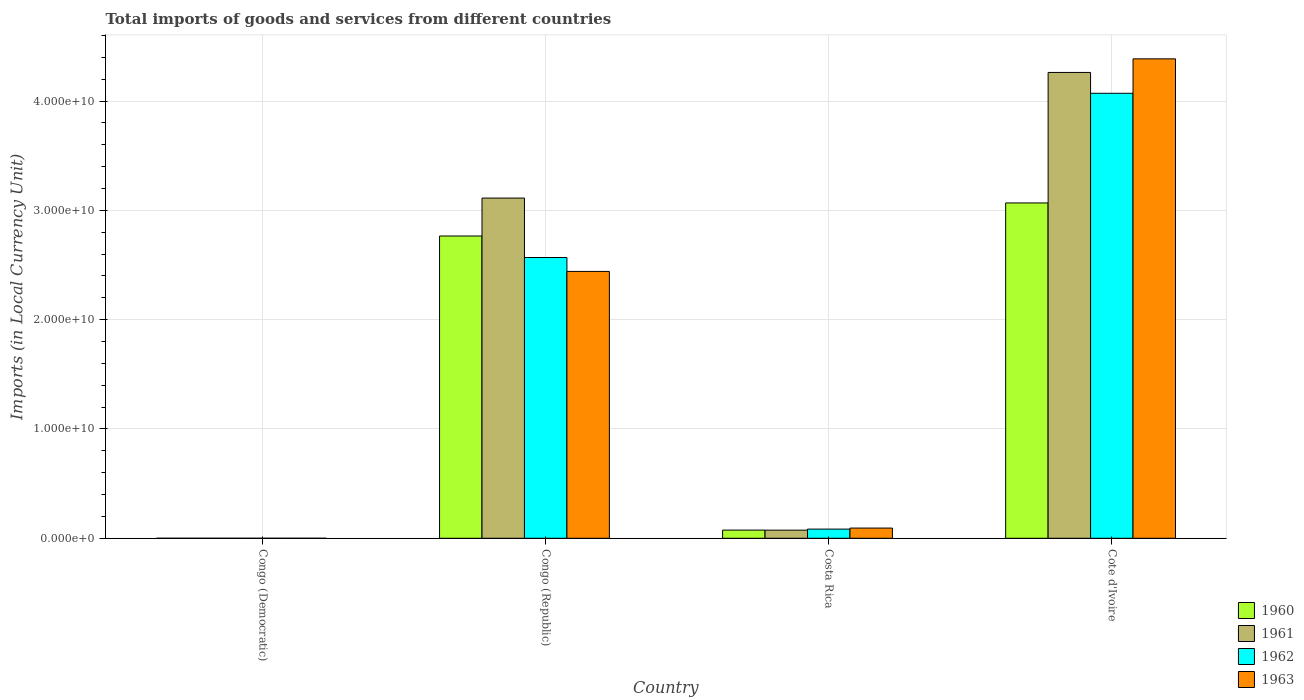How many different coloured bars are there?
Give a very brief answer. 4. How many groups of bars are there?
Your answer should be compact. 4. Are the number of bars on each tick of the X-axis equal?
Your answer should be compact. Yes. What is the label of the 4th group of bars from the left?
Your answer should be compact. Cote d'Ivoire. What is the Amount of goods and services imports in 1961 in Congo (Republic)?
Give a very brief answer. 3.11e+1. Across all countries, what is the maximum Amount of goods and services imports in 1961?
Keep it short and to the point. 4.26e+1. Across all countries, what is the minimum Amount of goods and services imports in 1960?
Ensure brevity in your answer.  0. In which country was the Amount of goods and services imports in 1962 maximum?
Provide a short and direct response. Cote d'Ivoire. In which country was the Amount of goods and services imports in 1961 minimum?
Ensure brevity in your answer.  Congo (Democratic). What is the total Amount of goods and services imports in 1963 in the graph?
Your answer should be compact. 6.92e+1. What is the difference between the Amount of goods and services imports in 1960 in Congo (Democratic) and that in Costa Rica?
Provide a succinct answer. -7.49e+08. What is the difference between the Amount of goods and services imports in 1963 in Costa Rica and the Amount of goods and services imports in 1961 in Congo (Republic)?
Your answer should be compact. -3.02e+1. What is the average Amount of goods and services imports in 1960 per country?
Your answer should be compact. 1.48e+1. What is the difference between the Amount of goods and services imports of/in 1963 and Amount of goods and services imports of/in 1960 in Costa Rica?
Offer a terse response. 1.85e+08. In how many countries, is the Amount of goods and services imports in 1960 greater than 42000000000 LCU?
Offer a terse response. 0. What is the ratio of the Amount of goods and services imports in 1962 in Congo (Republic) to that in Cote d'Ivoire?
Provide a succinct answer. 0.63. Is the Amount of goods and services imports in 1961 in Congo (Democratic) less than that in Congo (Republic)?
Offer a very short reply. Yes. Is the difference between the Amount of goods and services imports in 1963 in Congo (Republic) and Costa Rica greater than the difference between the Amount of goods and services imports in 1960 in Congo (Republic) and Costa Rica?
Your answer should be very brief. No. What is the difference between the highest and the second highest Amount of goods and services imports in 1962?
Give a very brief answer. -3.99e+1. What is the difference between the highest and the lowest Amount of goods and services imports in 1961?
Ensure brevity in your answer.  4.26e+1. In how many countries, is the Amount of goods and services imports in 1962 greater than the average Amount of goods and services imports in 1962 taken over all countries?
Keep it short and to the point. 2. Is it the case that in every country, the sum of the Amount of goods and services imports in 1962 and Amount of goods and services imports in 1963 is greater than the sum of Amount of goods and services imports in 1961 and Amount of goods and services imports in 1960?
Your answer should be very brief. No. What does the 4th bar from the left in Congo (Democratic) represents?
Offer a very short reply. 1963. Is it the case that in every country, the sum of the Amount of goods and services imports in 1963 and Amount of goods and services imports in 1961 is greater than the Amount of goods and services imports in 1962?
Keep it short and to the point. Yes. How many countries are there in the graph?
Your answer should be compact. 4. What is the difference between two consecutive major ticks on the Y-axis?
Your answer should be very brief. 1.00e+1. Are the values on the major ticks of Y-axis written in scientific E-notation?
Give a very brief answer. Yes. Where does the legend appear in the graph?
Provide a succinct answer. Bottom right. How are the legend labels stacked?
Your response must be concise. Vertical. What is the title of the graph?
Your response must be concise. Total imports of goods and services from different countries. What is the label or title of the X-axis?
Provide a short and direct response. Country. What is the label or title of the Y-axis?
Make the answer very short. Imports (in Local Currency Unit). What is the Imports (in Local Currency Unit) of 1960 in Congo (Democratic)?
Offer a terse response. 0. What is the Imports (in Local Currency Unit) in 1961 in Congo (Democratic)?
Provide a succinct answer. 5.07076656504069e-5. What is the Imports (in Local Currency Unit) of 1962 in Congo (Democratic)?
Your answer should be compact. 5.906629303353841e-5. What is the Imports (in Local Currency Unit) of 1963 in Congo (Democratic)?
Ensure brevity in your answer.  0. What is the Imports (in Local Currency Unit) of 1960 in Congo (Republic)?
Your response must be concise. 2.77e+1. What is the Imports (in Local Currency Unit) of 1961 in Congo (Republic)?
Provide a succinct answer. 3.11e+1. What is the Imports (in Local Currency Unit) in 1962 in Congo (Republic)?
Provide a succinct answer. 2.57e+1. What is the Imports (in Local Currency Unit) in 1963 in Congo (Republic)?
Provide a succinct answer. 2.44e+1. What is the Imports (in Local Currency Unit) of 1960 in Costa Rica?
Provide a short and direct response. 7.49e+08. What is the Imports (in Local Currency Unit) in 1961 in Costa Rica?
Ensure brevity in your answer.  7.44e+08. What is the Imports (in Local Currency Unit) in 1962 in Costa Rica?
Make the answer very short. 8.40e+08. What is the Imports (in Local Currency Unit) of 1963 in Costa Rica?
Make the answer very short. 9.34e+08. What is the Imports (in Local Currency Unit) in 1960 in Cote d'Ivoire?
Your answer should be compact. 3.07e+1. What is the Imports (in Local Currency Unit) in 1961 in Cote d'Ivoire?
Ensure brevity in your answer.  4.26e+1. What is the Imports (in Local Currency Unit) of 1962 in Cote d'Ivoire?
Your answer should be very brief. 4.07e+1. What is the Imports (in Local Currency Unit) in 1963 in Cote d'Ivoire?
Keep it short and to the point. 4.39e+1. Across all countries, what is the maximum Imports (in Local Currency Unit) of 1960?
Your response must be concise. 3.07e+1. Across all countries, what is the maximum Imports (in Local Currency Unit) in 1961?
Your answer should be compact. 4.26e+1. Across all countries, what is the maximum Imports (in Local Currency Unit) of 1962?
Keep it short and to the point. 4.07e+1. Across all countries, what is the maximum Imports (in Local Currency Unit) of 1963?
Offer a very short reply. 4.39e+1. Across all countries, what is the minimum Imports (in Local Currency Unit) of 1960?
Give a very brief answer. 0. Across all countries, what is the minimum Imports (in Local Currency Unit) of 1961?
Your answer should be compact. 5.07076656504069e-5. Across all countries, what is the minimum Imports (in Local Currency Unit) of 1962?
Provide a succinct answer. 5.906629303353841e-5. Across all countries, what is the minimum Imports (in Local Currency Unit) of 1963?
Ensure brevity in your answer.  0. What is the total Imports (in Local Currency Unit) of 1960 in the graph?
Your response must be concise. 5.91e+1. What is the total Imports (in Local Currency Unit) in 1961 in the graph?
Offer a very short reply. 7.45e+1. What is the total Imports (in Local Currency Unit) in 1962 in the graph?
Give a very brief answer. 6.72e+1. What is the total Imports (in Local Currency Unit) in 1963 in the graph?
Ensure brevity in your answer.  6.92e+1. What is the difference between the Imports (in Local Currency Unit) in 1960 in Congo (Democratic) and that in Congo (Republic)?
Provide a short and direct response. -2.77e+1. What is the difference between the Imports (in Local Currency Unit) in 1961 in Congo (Democratic) and that in Congo (Republic)?
Provide a short and direct response. -3.11e+1. What is the difference between the Imports (in Local Currency Unit) in 1962 in Congo (Democratic) and that in Congo (Republic)?
Offer a very short reply. -2.57e+1. What is the difference between the Imports (in Local Currency Unit) of 1963 in Congo (Democratic) and that in Congo (Republic)?
Your response must be concise. -2.44e+1. What is the difference between the Imports (in Local Currency Unit) in 1960 in Congo (Democratic) and that in Costa Rica?
Provide a short and direct response. -7.49e+08. What is the difference between the Imports (in Local Currency Unit) of 1961 in Congo (Democratic) and that in Costa Rica?
Make the answer very short. -7.44e+08. What is the difference between the Imports (in Local Currency Unit) in 1962 in Congo (Democratic) and that in Costa Rica?
Provide a short and direct response. -8.40e+08. What is the difference between the Imports (in Local Currency Unit) in 1963 in Congo (Democratic) and that in Costa Rica?
Make the answer very short. -9.34e+08. What is the difference between the Imports (in Local Currency Unit) in 1960 in Congo (Democratic) and that in Cote d'Ivoire?
Give a very brief answer. -3.07e+1. What is the difference between the Imports (in Local Currency Unit) of 1961 in Congo (Democratic) and that in Cote d'Ivoire?
Keep it short and to the point. -4.26e+1. What is the difference between the Imports (in Local Currency Unit) of 1962 in Congo (Democratic) and that in Cote d'Ivoire?
Your response must be concise. -4.07e+1. What is the difference between the Imports (in Local Currency Unit) of 1963 in Congo (Democratic) and that in Cote d'Ivoire?
Your answer should be very brief. -4.39e+1. What is the difference between the Imports (in Local Currency Unit) of 1960 in Congo (Republic) and that in Costa Rica?
Make the answer very short. 2.69e+1. What is the difference between the Imports (in Local Currency Unit) in 1961 in Congo (Republic) and that in Costa Rica?
Your answer should be compact. 3.04e+1. What is the difference between the Imports (in Local Currency Unit) in 1962 in Congo (Republic) and that in Costa Rica?
Offer a terse response. 2.48e+1. What is the difference between the Imports (in Local Currency Unit) in 1963 in Congo (Republic) and that in Costa Rica?
Provide a short and direct response. 2.35e+1. What is the difference between the Imports (in Local Currency Unit) of 1960 in Congo (Republic) and that in Cote d'Ivoire?
Your answer should be compact. -3.02e+09. What is the difference between the Imports (in Local Currency Unit) in 1961 in Congo (Republic) and that in Cote d'Ivoire?
Your answer should be very brief. -1.15e+1. What is the difference between the Imports (in Local Currency Unit) in 1962 in Congo (Republic) and that in Cote d'Ivoire?
Your answer should be very brief. -1.50e+1. What is the difference between the Imports (in Local Currency Unit) in 1963 in Congo (Republic) and that in Cote d'Ivoire?
Your answer should be very brief. -1.94e+1. What is the difference between the Imports (in Local Currency Unit) in 1960 in Costa Rica and that in Cote d'Ivoire?
Your response must be concise. -2.99e+1. What is the difference between the Imports (in Local Currency Unit) of 1961 in Costa Rica and that in Cote d'Ivoire?
Provide a succinct answer. -4.19e+1. What is the difference between the Imports (in Local Currency Unit) in 1962 in Costa Rica and that in Cote d'Ivoire?
Give a very brief answer. -3.99e+1. What is the difference between the Imports (in Local Currency Unit) of 1963 in Costa Rica and that in Cote d'Ivoire?
Make the answer very short. -4.29e+1. What is the difference between the Imports (in Local Currency Unit) of 1960 in Congo (Democratic) and the Imports (in Local Currency Unit) of 1961 in Congo (Republic)?
Your answer should be compact. -3.11e+1. What is the difference between the Imports (in Local Currency Unit) in 1960 in Congo (Democratic) and the Imports (in Local Currency Unit) in 1962 in Congo (Republic)?
Give a very brief answer. -2.57e+1. What is the difference between the Imports (in Local Currency Unit) in 1960 in Congo (Democratic) and the Imports (in Local Currency Unit) in 1963 in Congo (Republic)?
Offer a terse response. -2.44e+1. What is the difference between the Imports (in Local Currency Unit) of 1961 in Congo (Democratic) and the Imports (in Local Currency Unit) of 1962 in Congo (Republic)?
Ensure brevity in your answer.  -2.57e+1. What is the difference between the Imports (in Local Currency Unit) of 1961 in Congo (Democratic) and the Imports (in Local Currency Unit) of 1963 in Congo (Republic)?
Keep it short and to the point. -2.44e+1. What is the difference between the Imports (in Local Currency Unit) of 1962 in Congo (Democratic) and the Imports (in Local Currency Unit) of 1963 in Congo (Republic)?
Keep it short and to the point. -2.44e+1. What is the difference between the Imports (in Local Currency Unit) of 1960 in Congo (Democratic) and the Imports (in Local Currency Unit) of 1961 in Costa Rica?
Offer a very short reply. -7.44e+08. What is the difference between the Imports (in Local Currency Unit) of 1960 in Congo (Democratic) and the Imports (in Local Currency Unit) of 1962 in Costa Rica?
Give a very brief answer. -8.40e+08. What is the difference between the Imports (in Local Currency Unit) of 1960 in Congo (Democratic) and the Imports (in Local Currency Unit) of 1963 in Costa Rica?
Keep it short and to the point. -9.34e+08. What is the difference between the Imports (in Local Currency Unit) in 1961 in Congo (Democratic) and the Imports (in Local Currency Unit) in 1962 in Costa Rica?
Make the answer very short. -8.40e+08. What is the difference between the Imports (in Local Currency Unit) of 1961 in Congo (Democratic) and the Imports (in Local Currency Unit) of 1963 in Costa Rica?
Your answer should be very brief. -9.34e+08. What is the difference between the Imports (in Local Currency Unit) of 1962 in Congo (Democratic) and the Imports (in Local Currency Unit) of 1963 in Costa Rica?
Your answer should be compact. -9.34e+08. What is the difference between the Imports (in Local Currency Unit) of 1960 in Congo (Democratic) and the Imports (in Local Currency Unit) of 1961 in Cote d'Ivoire?
Offer a very short reply. -4.26e+1. What is the difference between the Imports (in Local Currency Unit) of 1960 in Congo (Democratic) and the Imports (in Local Currency Unit) of 1962 in Cote d'Ivoire?
Make the answer very short. -4.07e+1. What is the difference between the Imports (in Local Currency Unit) in 1960 in Congo (Democratic) and the Imports (in Local Currency Unit) in 1963 in Cote d'Ivoire?
Provide a succinct answer. -4.39e+1. What is the difference between the Imports (in Local Currency Unit) in 1961 in Congo (Democratic) and the Imports (in Local Currency Unit) in 1962 in Cote d'Ivoire?
Your response must be concise. -4.07e+1. What is the difference between the Imports (in Local Currency Unit) of 1961 in Congo (Democratic) and the Imports (in Local Currency Unit) of 1963 in Cote d'Ivoire?
Your response must be concise. -4.39e+1. What is the difference between the Imports (in Local Currency Unit) of 1962 in Congo (Democratic) and the Imports (in Local Currency Unit) of 1963 in Cote d'Ivoire?
Your answer should be compact. -4.39e+1. What is the difference between the Imports (in Local Currency Unit) in 1960 in Congo (Republic) and the Imports (in Local Currency Unit) in 1961 in Costa Rica?
Offer a terse response. 2.69e+1. What is the difference between the Imports (in Local Currency Unit) in 1960 in Congo (Republic) and the Imports (in Local Currency Unit) in 1962 in Costa Rica?
Make the answer very short. 2.68e+1. What is the difference between the Imports (in Local Currency Unit) in 1960 in Congo (Republic) and the Imports (in Local Currency Unit) in 1963 in Costa Rica?
Your answer should be compact. 2.67e+1. What is the difference between the Imports (in Local Currency Unit) in 1961 in Congo (Republic) and the Imports (in Local Currency Unit) in 1962 in Costa Rica?
Provide a succinct answer. 3.03e+1. What is the difference between the Imports (in Local Currency Unit) in 1961 in Congo (Republic) and the Imports (in Local Currency Unit) in 1963 in Costa Rica?
Provide a short and direct response. 3.02e+1. What is the difference between the Imports (in Local Currency Unit) of 1962 in Congo (Republic) and the Imports (in Local Currency Unit) of 1963 in Costa Rica?
Keep it short and to the point. 2.48e+1. What is the difference between the Imports (in Local Currency Unit) of 1960 in Congo (Republic) and the Imports (in Local Currency Unit) of 1961 in Cote d'Ivoire?
Your response must be concise. -1.50e+1. What is the difference between the Imports (in Local Currency Unit) in 1960 in Congo (Republic) and the Imports (in Local Currency Unit) in 1962 in Cote d'Ivoire?
Your answer should be compact. -1.31e+1. What is the difference between the Imports (in Local Currency Unit) in 1960 in Congo (Republic) and the Imports (in Local Currency Unit) in 1963 in Cote d'Ivoire?
Keep it short and to the point. -1.62e+1. What is the difference between the Imports (in Local Currency Unit) in 1961 in Congo (Republic) and the Imports (in Local Currency Unit) in 1962 in Cote d'Ivoire?
Offer a very short reply. -9.58e+09. What is the difference between the Imports (in Local Currency Unit) in 1961 in Congo (Republic) and the Imports (in Local Currency Unit) in 1963 in Cote d'Ivoire?
Provide a short and direct response. -1.27e+1. What is the difference between the Imports (in Local Currency Unit) in 1962 in Congo (Republic) and the Imports (in Local Currency Unit) in 1963 in Cote d'Ivoire?
Your response must be concise. -1.82e+1. What is the difference between the Imports (in Local Currency Unit) in 1960 in Costa Rica and the Imports (in Local Currency Unit) in 1961 in Cote d'Ivoire?
Give a very brief answer. -4.19e+1. What is the difference between the Imports (in Local Currency Unit) in 1960 in Costa Rica and the Imports (in Local Currency Unit) in 1962 in Cote d'Ivoire?
Your response must be concise. -4.00e+1. What is the difference between the Imports (in Local Currency Unit) of 1960 in Costa Rica and the Imports (in Local Currency Unit) of 1963 in Cote d'Ivoire?
Your answer should be compact. -4.31e+1. What is the difference between the Imports (in Local Currency Unit) in 1961 in Costa Rica and the Imports (in Local Currency Unit) in 1962 in Cote d'Ivoire?
Your response must be concise. -4.00e+1. What is the difference between the Imports (in Local Currency Unit) in 1961 in Costa Rica and the Imports (in Local Currency Unit) in 1963 in Cote d'Ivoire?
Offer a very short reply. -4.31e+1. What is the difference between the Imports (in Local Currency Unit) of 1962 in Costa Rica and the Imports (in Local Currency Unit) of 1963 in Cote d'Ivoire?
Give a very brief answer. -4.30e+1. What is the average Imports (in Local Currency Unit) in 1960 per country?
Your answer should be very brief. 1.48e+1. What is the average Imports (in Local Currency Unit) of 1961 per country?
Your answer should be very brief. 1.86e+1. What is the average Imports (in Local Currency Unit) of 1962 per country?
Your answer should be very brief. 1.68e+1. What is the average Imports (in Local Currency Unit) in 1963 per country?
Provide a short and direct response. 1.73e+1. What is the difference between the Imports (in Local Currency Unit) of 1960 and Imports (in Local Currency Unit) of 1963 in Congo (Democratic)?
Your response must be concise. -0. What is the difference between the Imports (in Local Currency Unit) in 1961 and Imports (in Local Currency Unit) in 1963 in Congo (Democratic)?
Provide a short and direct response. -0. What is the difference between the Imports (in Local Currency Unit) of 1962 and Imports (in Local Currency Unit) of 1963 in Congo (Democratic)?
Your answer should be very brief. -0. What is the difference between the Imports (in Local Currency Unit) of 1960 and Imports (in Local Currency Unit) of 1961 in Congo (Republic)?
Offer a terse response. -3.47e+09. What is the difference between the Imports (in Local Currency Unit) in 1960 and Imports (in Local Currency Unit) in 1962 in Congo (Republic)?
Provide a short and direct response. 1.97e+09. What is the difference between the Imports (in Local Currency Unit) in 1960 and Imports (in Local Currency Unit) in 1963 in Congo (Republic)?
Make the answer very short. 3.24e+09. What is the difference between the Imports (in Local Currency Unit) in 1961 and Imports (in Local Currency Unit) in 1962 in Congo (Republic)?
Make the answer very short. 5.44e+09. What is the difference between the Imports (in Local Currency Unit) of 1961 and Imports (in Local Currency Unit) of 1963 in Congo (Republic)?
Make the answer very short. 6.71e+09. What is the difference between the Imports (in Local Currency Unit) in 1962 and Imports (in Local Currency Unit) in 1963 in Congo (Republic)?
Ensure brevity in your answer.  1.27e+09. What is the difference between the Imports (in Local Currency Unit) in 1960 and Imports (in Local Currency Unit) in 1961 in Costa Rica?
Offer a very short reply. 4.80e+06. What is the difference between the Imports (in Local Currency Unit) of 1960 and Imports (in Local Currency Unit) of 1962 in Costa Rica?
Your answer should be compact. -9.07e+07. What is the difference between the Imports (in Local Currency Unit) in 1960 and Imports (in Local Currency Unit) in 1963 in Costa Rica?
Offer a terse response. -1.85e+08. What is the difference between the Imports (in Local Currency Unit) in 1961 and Imports (in Local Currency Unit) in 1962 in Costa Rica?
Keep it short and to the point. -9.55e+07. What is the difference between the Imports (in Local Currency Unit) of 1961 and Imports (in Local Currency Unit) of 1963 in Costa Rica?
Keep it short and to the point. -1.90e+08. What is the difference between the Imports (in Local Currency Unit) of 1962 and Imports (in Local Currency Unit) of 1963 in Costa Rica?
Make the answer very short. -9.44e+07. What is the difference between the Imports (in Local Currency Unit) in 1960 and Imports (in Local Currency Unit) in 1961 in Cote d'Ivoire?
Your response must be concise. -1.19e+1. What is the difference between the Imports (in Local Currency Unit) of 1960 and Imports (in Local Currency Unit) of 1962 in Cote d'Ivoire?
Offer a very short reply. -1.00e+1. What is the difference between the Imports (in Local Currency Unit) of 1960 and Imports (in Local Currency Unit) of 1963 in Cote d'Ivoire?
Ensure brevity in your answer.  -1.32e+1. What is the difference between the Imports (in Local Currency Unit) in 1961 and Imports (in Local Currency Unit) in 1962 in Cote d'Ivoire?
Provide a succinct answer. 1.91e+09. What is the difference between the Imports (in Local Currency Unit) of 1961 and Imports (in Local Currency Unit) of 1963 in Cote d'Ivoire?
Your response must be concise. -1.24e+09. What is the difference between the Imports (in Local Currency Unit) in 1962 and Imports (in Local Currency Unit) in 1963 in Cote d'Ivoire?
Offer a very short reply. -3.15e+09. What is the ratio of the Imports (in Local Currency Unit) in 1960 in Congo (Democratic) to that in Congo (Republic)?
Provide a short and direct response. 0. What is the ratio of the Imports (in Local Currency Unit) of 1962 in Congo (Democratic) to that in Congo (Republic)?
Ensure brevity in your answer.  0. What is the ratio of the Imports (in Local Currency Unit) of 1961 in Congo (Democratic) to that in Costa Rica?
Provide a succinct answer. 0. What is the ratio of the Imports (in Local Currency Unit) in 1962 in Congo (Democratic) to that in Costa Rica?
Offer a very short reply. 0. What is the ratio of the Imports (in Local Currency Unit) in 1963 in Congo (Democratic) to that in Costa Rica?
Offer a terse response. 0. What is the ratio of the Imports (in Local Currency Unit) of 1960 in Congo (Democratic) to that in Cote d'Ivoire?
Keep it short and to the point. 0. What is the ratio of the Imports (in Local Currency Unit) of 1963 in Congo (Democratic) to that in Cote d'Ivoire?
Your response must be concise. 0. What is the ratio of the Imports (in Local Currency Unit) in 1960 in Congo (Republic) to that in Costa Rica?
Offer a very short reply. 36.93. What is the ratio of the Imports (in Local Currency Unit) in 1961 in Congo (Republic) to that in Costa Rica?
Provide a succinct answer. 41.83. What is the ratio of the Imports (in Local Currency Unit) in 1962 in Congo (Republic) to that in Costa Rica?
Make the answer very short. 30.59. What is the ratio of the Imports (in Local Currency Unit) in 1963 in Congo (Republic) to that in Costa Rica?
Your answer should be very brief. 26.14. What is the ratio of the Imports (in Local Currency Unit) in 1960 in Congo (Republic) to that in Cote d'Ivoire?
Give a very brief answer. 0.9. What is the ratio of the Imports (in Local Currency Unit) in 1961 in Congo (Republic) to that in Cote d'Ivoire?
Offer a very short reply. 0.73. What is the ratio of the Imports (in Local Currency Unit) of 1962 in Congo (Republic) to that in Cote d'Ivoire?
Your answer should be compact. 0.63. What is the ratio of the Imports (in Local Currency Unit) in 1963 in Congo (Republic) to that in Cote d'Ivoire?
Your response must be concise. 0.56. What is the ratio of the Imports (in Local Currency Unit) in 1960 in Costa Rica to that in Cote d'Ivoire?
Make the answer very short. 0.02. What is the ratio of the Imports (in Local Currency Unit) of 1961 in Costa Rica to that in Cote d'Ivoire?
Your response must be concise. 0.02. What is the ratio of the Imports (in Local Currency Unit) in 1962 in Costa Rica to that in Cote d'Ivoire?
Make the answer very short. 0.02. What is the ratio of the Imports (in Local Currency Unit) in 1963 in Costa Rica to that in Cote d'Ivoire?
Your answer should be compact. 0.02. What is the difference between the highest and the second highest Imports (in Local Currency Unit) of 1960?
Offer a terse response. 3.02e+09. What is the difference between the highest and the second highest Imports (in Local Currency Unit) of 1961?
Offer a terse response. 1.15e+1. What is the difference between the highest and the second highest Imports (in Local Currency Unit) in 1962?
Your answer should be very brief. 1.50e+1. What is the difference between the highest and the second highest Imports (in Local Currency Unit) in 1963?
Offer a terse response. 1.94e+1. What is the difference between the highest and the lowest Imports (in Local Currency Unit) of 1960?
Your response must be concise. 3.07e+1. What is the difference between the highest and the lowest Imports (in Local Currency Unit) in 1961?
Offer a very short reply. 4.26e+1. What is the difference between the highest and the lowest Imports (in Local Currency Unit) of 1962?
Give a very brief answer. 4.07e+1. What is the difference between the highest and the lowest Imports (in Local Currency Unit) in 1963?
Make the answer very short. 4.39e+1. 